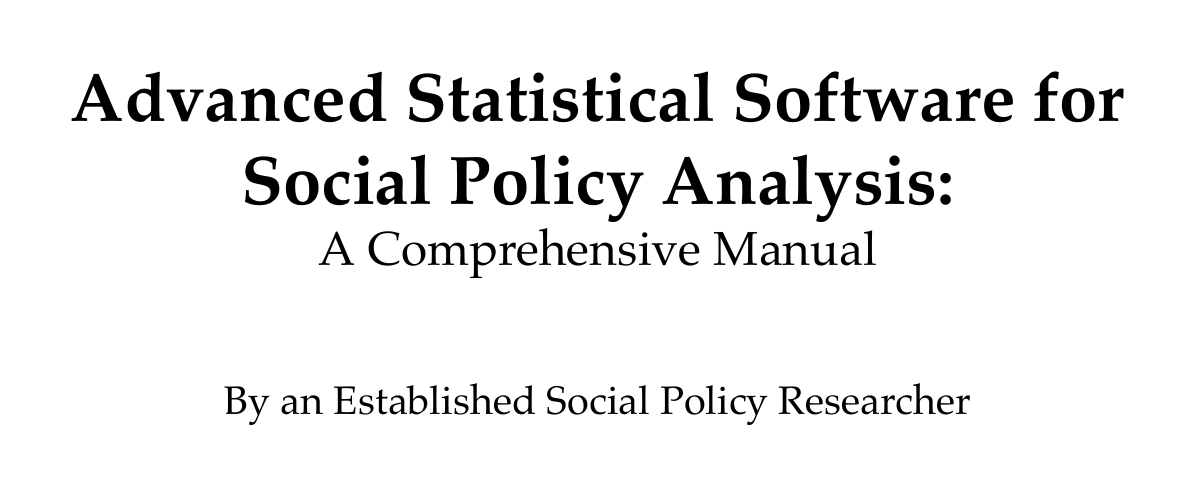What software packages are compared in the manual? The manual compares STATA, R, SPSS, and SAS for social policy analysis.
Answer: STATA, R, SPSS, and SAS What is the focus of the chapter on data management techniques? This chapter focuses on importing, cleaning, manipulating, transforming, merging, and appending datasets.
Answer: Data management techniques What is the purpose of propensity score matching? Propensity score matching is implemented for causal inference in quasi-experimental policy evaluations.
Answer: Causal inference What type of regression analysis is used to analyze categorical outcomes? The manual discusses binary and multinomial logistic regression for analyzing categorical outcomes.
Answer: Logistic regression Which section covers interactive visualizations? The section titled "Interactive visualizations" discusses using ggplot2 in R and Plotly for creating dynamic visualizations.
Answer: Interactive visualizations What is the main content of Appendix B? Appendix B lists reputable data sources, including the American Community Survey and Current Population Survey.
Answer: Data Sources for Social Policy Research How many chapters are in the manual? The document outlines a total of seven chapters, including appendices.
Answer: Seven chapters What approach does the case study on minimum wage policies utilize? The case study on minimum wage policies uses panel data and difference-in-differences approach.
Answer: Panel data and difference-in-differences approach 